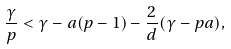Convert formula to latex. <formula><loc_0><loc_0><loc_500><loc_500>\frac { \gamma } { p } < \gamma - a ( p - 1 ) - \frac { 2 } { d } ( \gamma - p a ) ,</formula> 